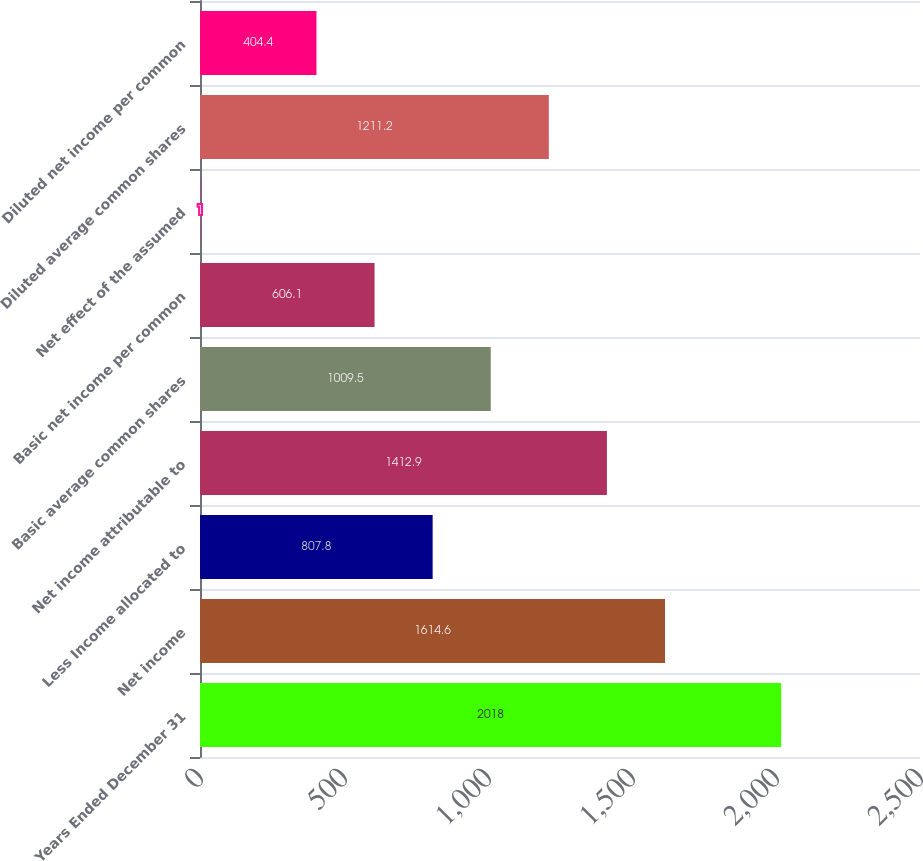Convert chart. <chart><loc_0><loc_0><loc_500><loc_500><bar_chart><fcel>Years Ended December 31<fcel>Net income<fcel>Less Income allocated to<fcel>Net income attributable to<fcel>Basic average common shares<fcel>Basic net income per common<fcel>Net effect of the assumed<fcel>Diluted average common shares<fcel>Diluted net income per common<nl><fcel>2018<fcel>1614.6<fcel>807.8<fcel>1412.9<fcel>1009.5<fcel>606.1<fcel>1<fcel>1211.2<fcel>404.4<nl></chart> 